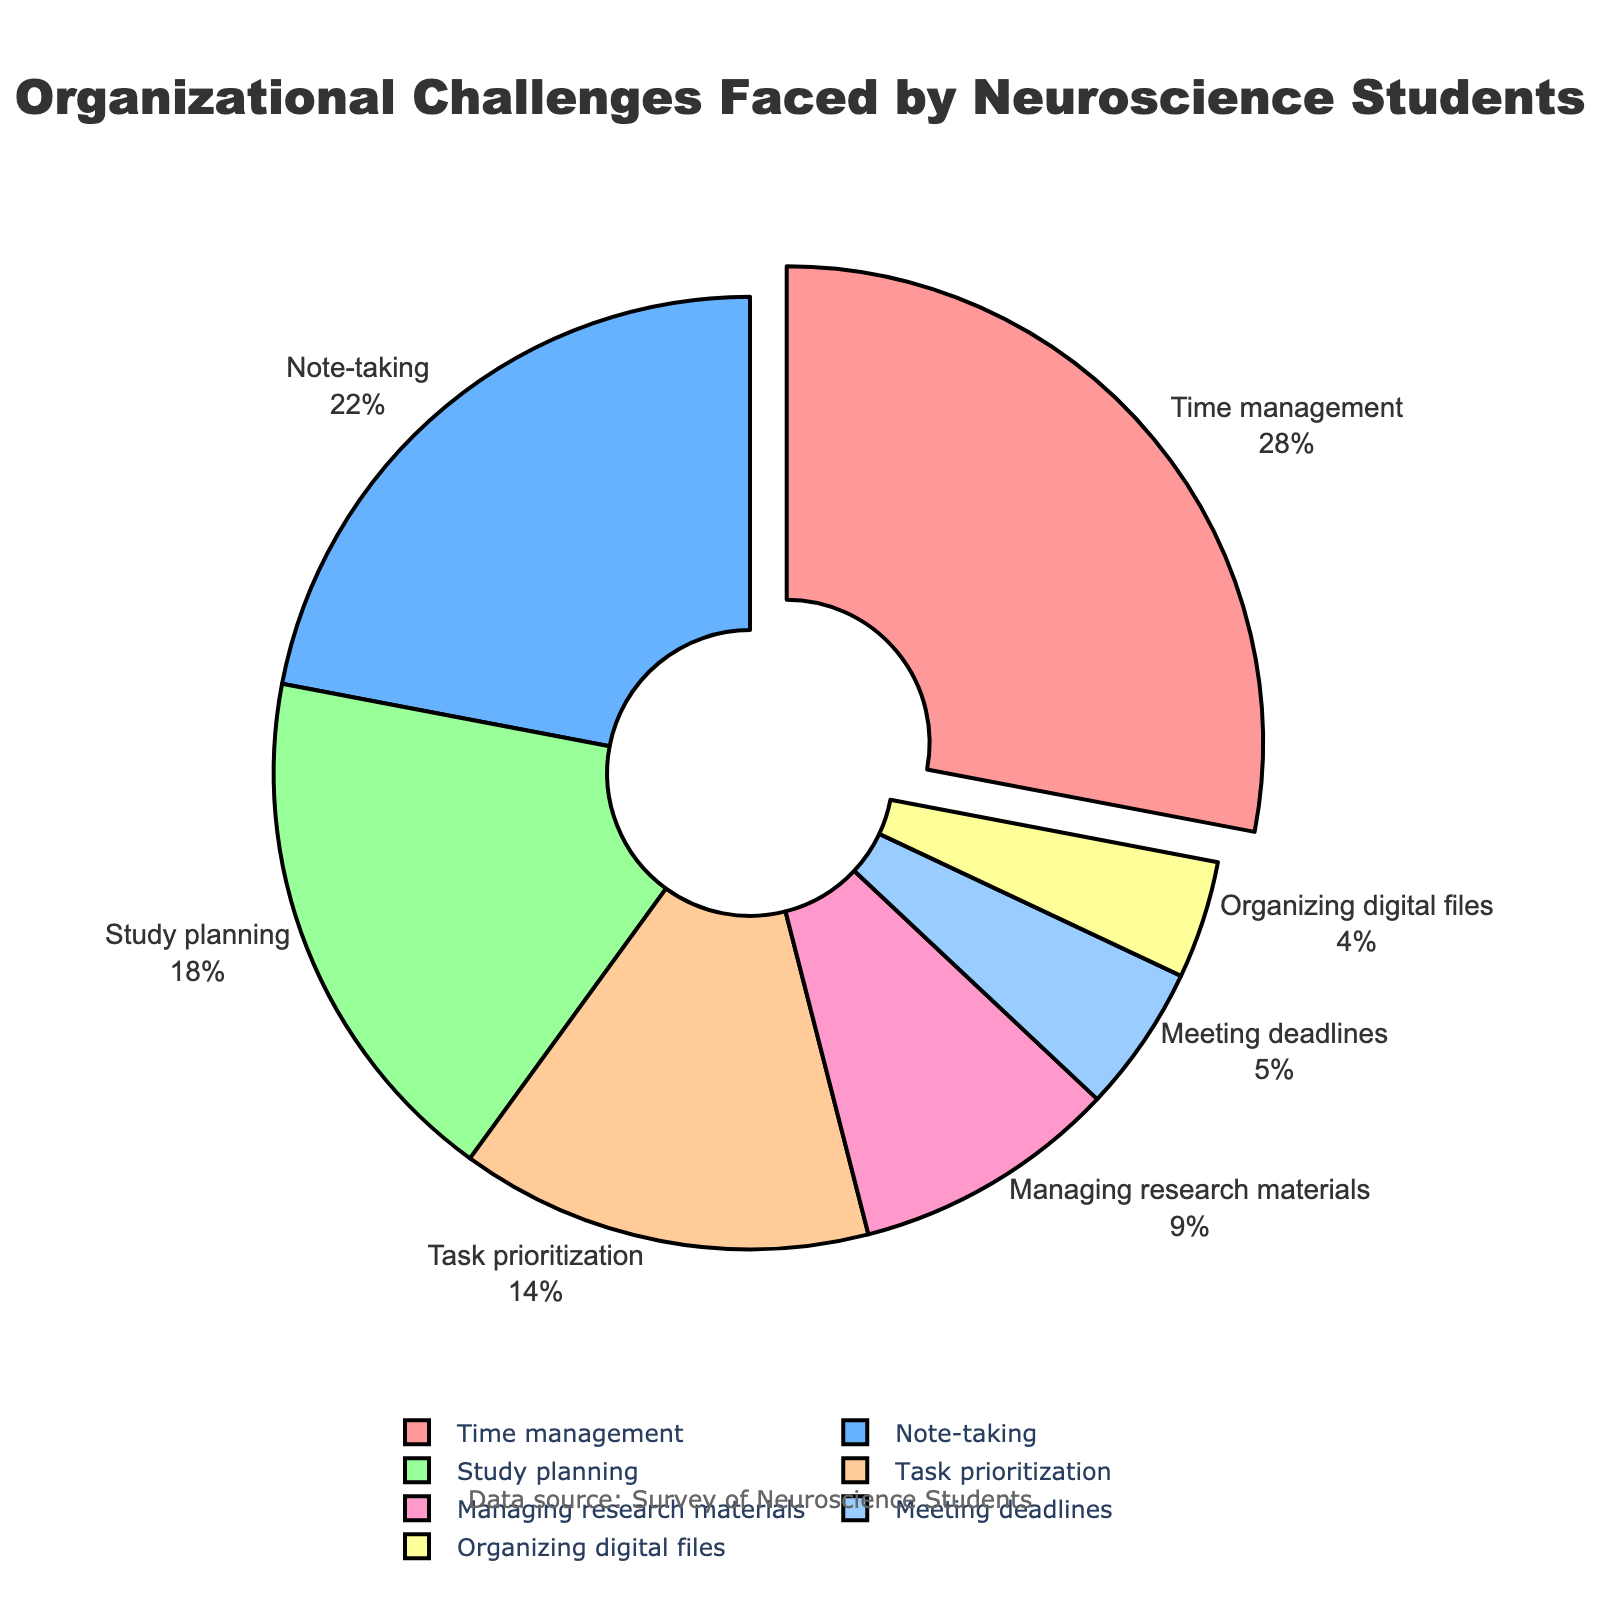Which challenge is reported by the highest percentage of neuroscience students? By referring to the pie chart, the challenge with the largest section is marked. The corresponding percentage is 28%.
Answer: Time management What is the combined percentage of students reporting difficulties in task prioritization and managing research materials? Add the percentages for task prioritization (14%) and managing research materials (9%): 14 + 9 = 23%.
Answer: 23% How many times larger is the percentage of students struggling with time management compared to those struggling with organizing digital files? Divide the percentage for time management (28%) by the percentage for organizing digital files (4%): 28 / 4 = 7.
Answer: 7 Which organizational challenge is reported by fewer students, meeting deadlines or managing research materials? Compare their percentages, with meeting deadlines at 5% and managing research materials at 9%. Since 5 is less than 9, meeting deadlines is the lesser-reported challenge.
Answer: Meeting deadlines What is the percentage difference between students struggling with note-taking and study planning? Subtract the percentage for study planning (18%) from note-taking (22%): 22 - 18 = 4%.
Answer: 4% Which section is represented in green, and what percentage does it denote? The green section of the pie chart represents study planning. The corresponding percentage is 18%.
Answer: Study planning, 18% What proportion of students face challenges with time management relative to the total? Time management accounts for 28% of the challenges. This percentage directly represents the proportion of students facing this difficulty.
Answer: 28% If we combine the least and the second least reported challenges, what is the total percentage? Add the percentages for the least (organizing digital files, 4%) and the second least (meeting deadlines, 5%): 4 + 5 = 9%.
Answer: 9% Which challenge lies in between managing research materials and note-taking in terms of the percentage reported? From the figure, study planning (18%) falls between managing research materials (9%) and note-taking (22%).
Answer: Study planning Are there more students facing difficulty in study planning or task prioritization? Study planning has 18%, and task prioritization has 14%. Since 18 is greater than 14, more students face difficulty in study planning.
Answer: Study planning 